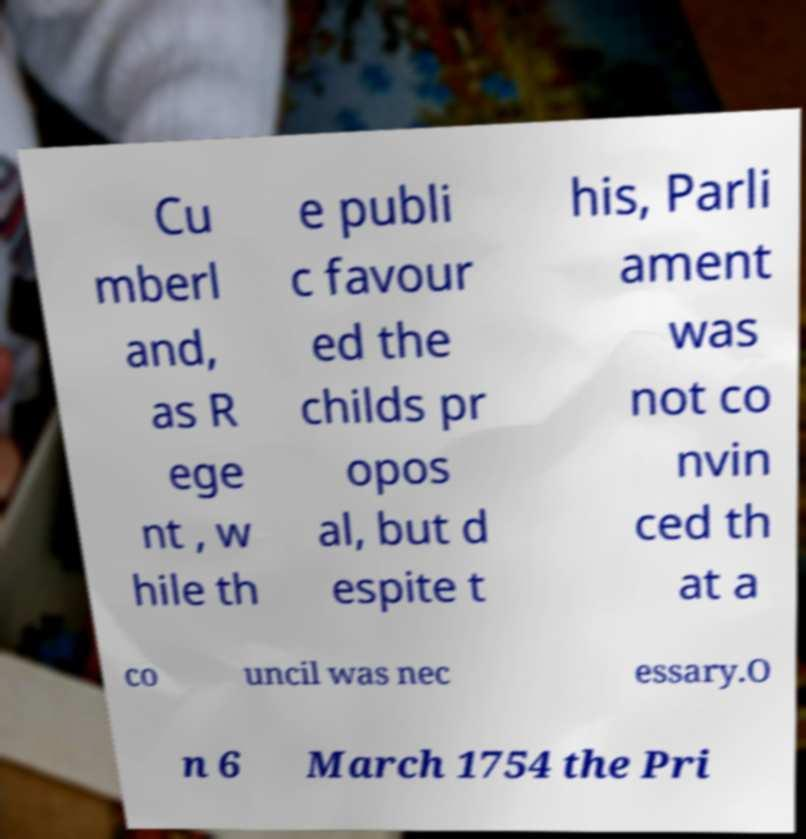I need the written content from this picture converted into text. Can you do that? Cu mberl and, as R ege nt , w hile th e publi c favour ed the childs pr opos al, but d espite t his, Parli ament was not co nvin ced th at a co uncil was nec essary.O n 6 March 1754 the Pri 